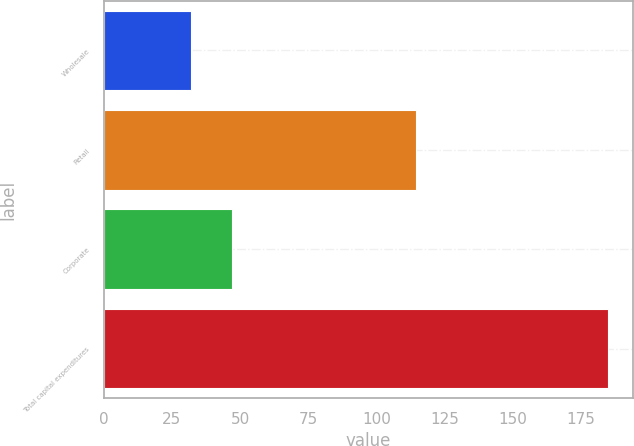<chart> <loc_0><loc_0><loc_500><loc_500><bar_chart><fcel>Wholesale<fcel>Retail<fcel>Corporate<fcel>Total capital expenditures<nl><fcel>31.8<fcel>114.5<fcel>47.12<fcel>185<nl></chart> 